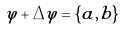<formula> <loc_0><loc_0><loc_500><loc_500>\varphi + \Delta \varphi = \{ a , b \}</formula> 